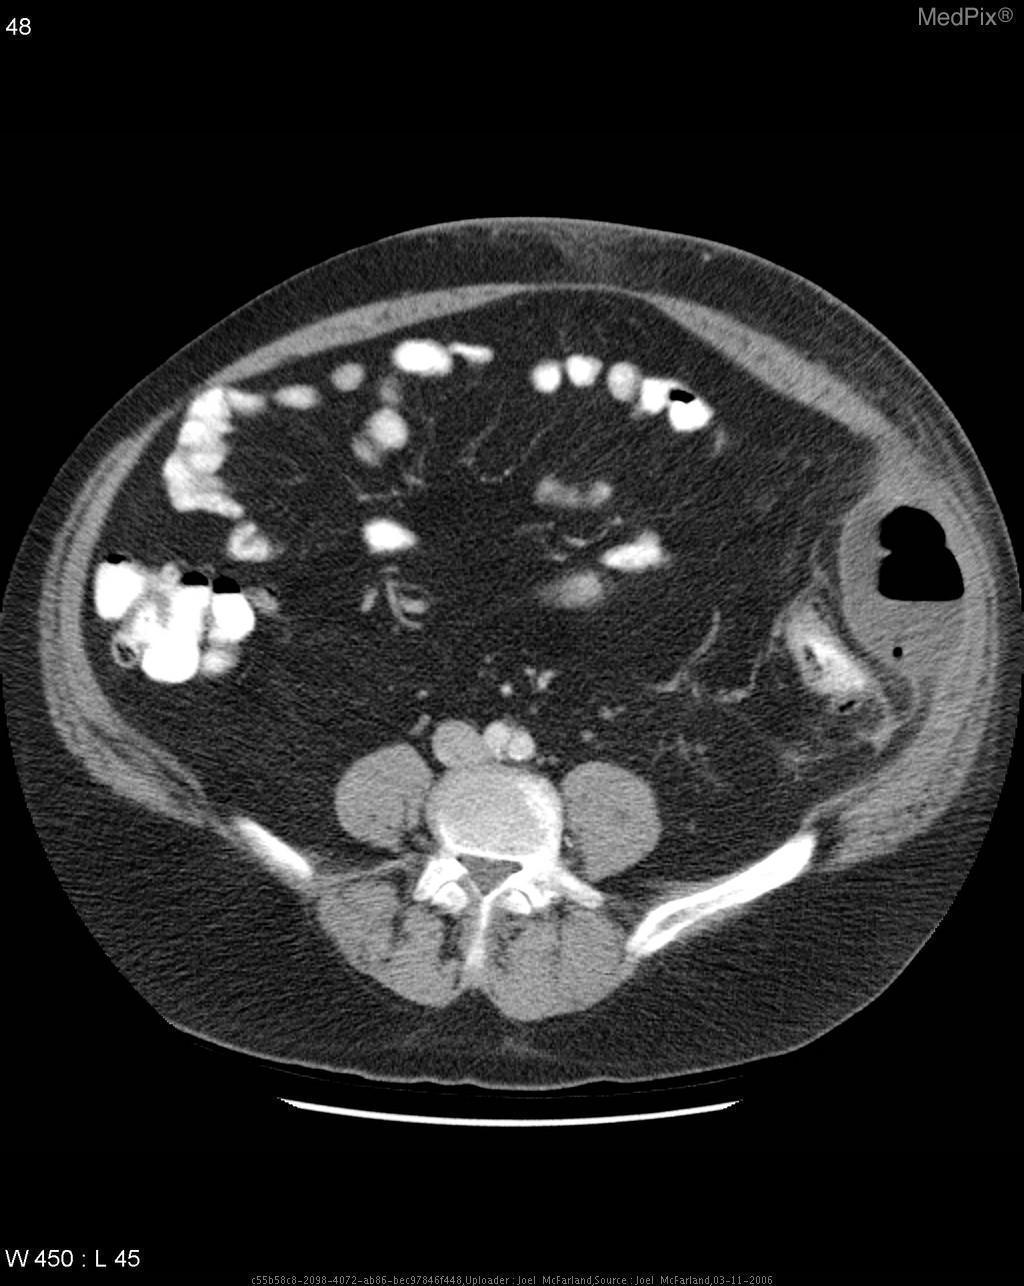Are air fluid levels depicted in this image?
Answer briefly. Yes. Is there an air fluid level present?
Concise answer only. Yes. How was this image taken?
Short answer required. With contrast. Is this an axial plane?
Short answer required. Yes. The abscess is located in what structure?
Quick response, please. Descending colon. Where is the abscess located?
Quick response, please. Descending colon. Where are the kidneys located?
Answer briefly. Adjacent to vertebrae. Was contrast used?
Short answer required. Yes. Is there fat stranding present?
Be succinct. No. Is fat stranding depicted in this image?
Answer briefly. No. 